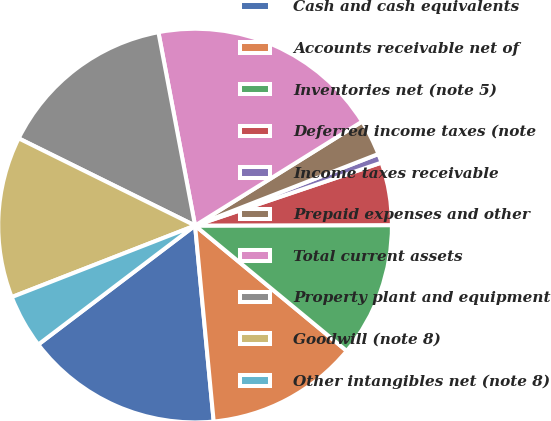<chart> <loc_0><loc_0><loc_500><loc_500><pie_chart><fcel>Cash and cash equivalents<fcel>Accounts receivable net of<fcel>Inventories net (note 5)<fcel>Deferred income taxes (note<fcel>Income taxes receivable<fcel>Prepaid expenses and other<fcel>Total current assets<fcel>Property plant and equipment<fcel>Goodwill (note 8)<fcel>Other intangibles net (note 8)<nl><fcel>16.18%<fcel>12.5%<fcel>11.03%<fcel>5.15%<fcel>0.74%<fcel>2.94%<fcel>19.12%<fcel>14.71%<fcel>13.23%<fcel>4.41%<nl></chart> 